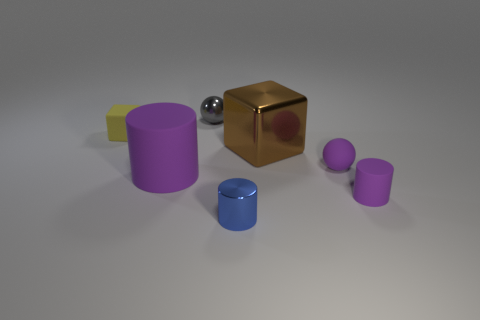There is a brown object; what number of tiny metal balls are in front of it?
Give a very brief answer. 0. How many other objects are the same color as the small rubber block?
Provide a succinct answer. 0. Are there fewer tiny yellow objects on the left side of the matte cube than tiny matte balls to the right of the small gray metal ball?
Offer a very short reply. Yes. How many things are small gray shiny objects to the right of the large purple matte cylinder or blue metallic things?
Your response must be concise. 2. Do the brown object and the purple matte cylinder that is on the left side of the brown metallic object have the same size?
Provide a succinct answer. Yes. There is another object that is the same shape as the small gray metal object; what is its size?
Keep it short and to the point. Small. How many tiny yellow cubes are on the right side of the tiny matte object that is in front of the purple rubber thing that is on the left side of the blue cylinder?
Your answer should be very brief. 0. How many blocks are either small shiny things or blue things?
Your answer should be very brief. 0. There is a small metallic thing that is in front of the purple object on the left side of the block that is to the right of the gray ball; what is its color?
Make the answer very short. Blue. What number of other objects are the same size as the purple ball?
Give a very brief answer. 4. 